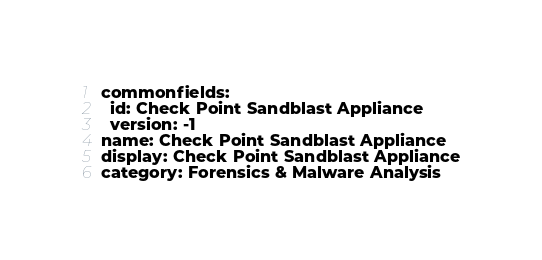Convert code to text. <code><loc_0><loc_0><loc_500><loc_500><_YAML_>commonfields:
  id: Check Point Sandblast Appliance
  version: -1
name: Check Point Sandblast Appliance
display: Check Point Sandblast Appliance
category: Forensics & Malware Analysis</code> 